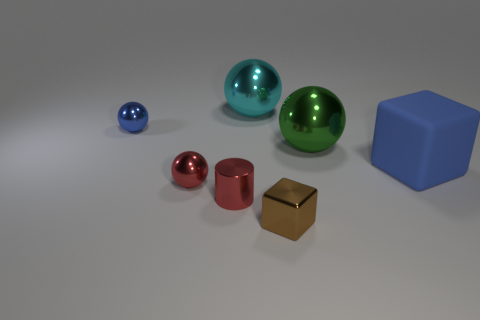Is there anything else that is made of the same material as the big blue block?
Offer a very short reply. No. What is the color of the small object that is behind the big blue rubber cube?
Your response must be concise. Blue. There is a cyan ball that is made of the same material as the big green thing; what is its size?
Make the answer very short. Large. There is a red thing that is the same shape as the large cyan metallic object; what size is it?
Ensure brevity in your answer.  Small. Is there a small red metallic cylinder?
Keep it short and to the point. Yes. What number of objects are either metallic spheres in front of the large blue block or large blue spheres?
Ensure brevity in your answer.  1. There is a block that is the same size as the cyan metal ball; what material is it?
Offer a terse response. Rubber. What is the color of the block in front of the metallic ball in front of the big blue matte block?
Give a very brief answer. Brown. There is a matte block; what number of large blue rubber things are behind it?
Provide a short and direct response. 0. The large rubber object has what color?
Your response must be concise. Blue. 